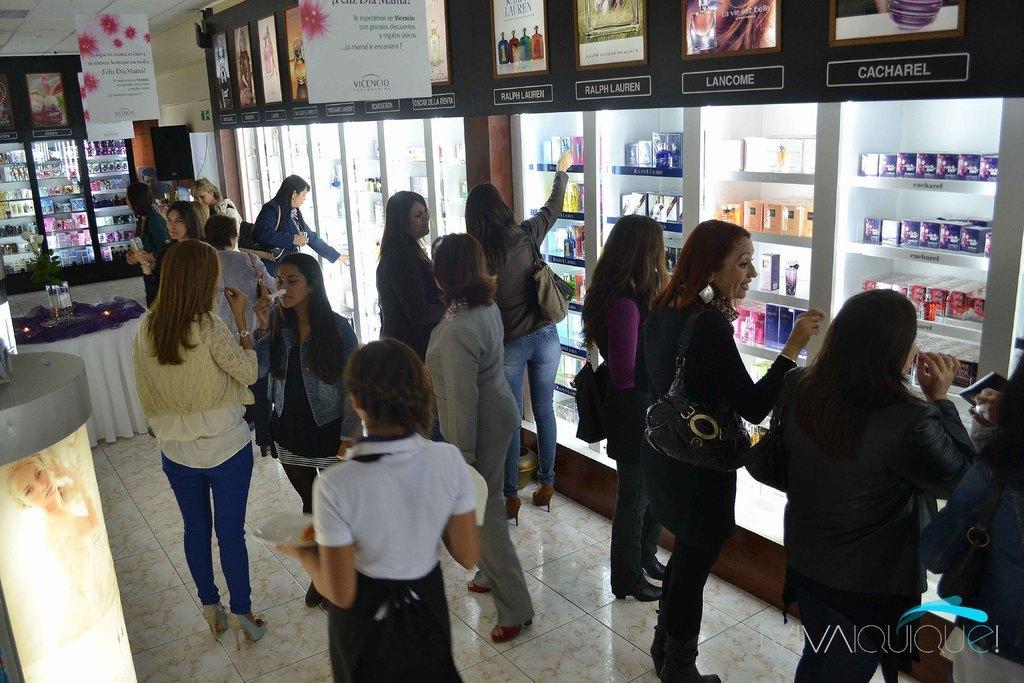Can you describe this image briefly? In the picture I can see a group of women standing on the floor. I can see a few women carrying the bags and a few of them smiling. I can see the cosmetics in the glass display cabinet. I can see the table on the floor on the left side. I can see the posters on the wall which resembles the cosmetics at the top of the picture. 